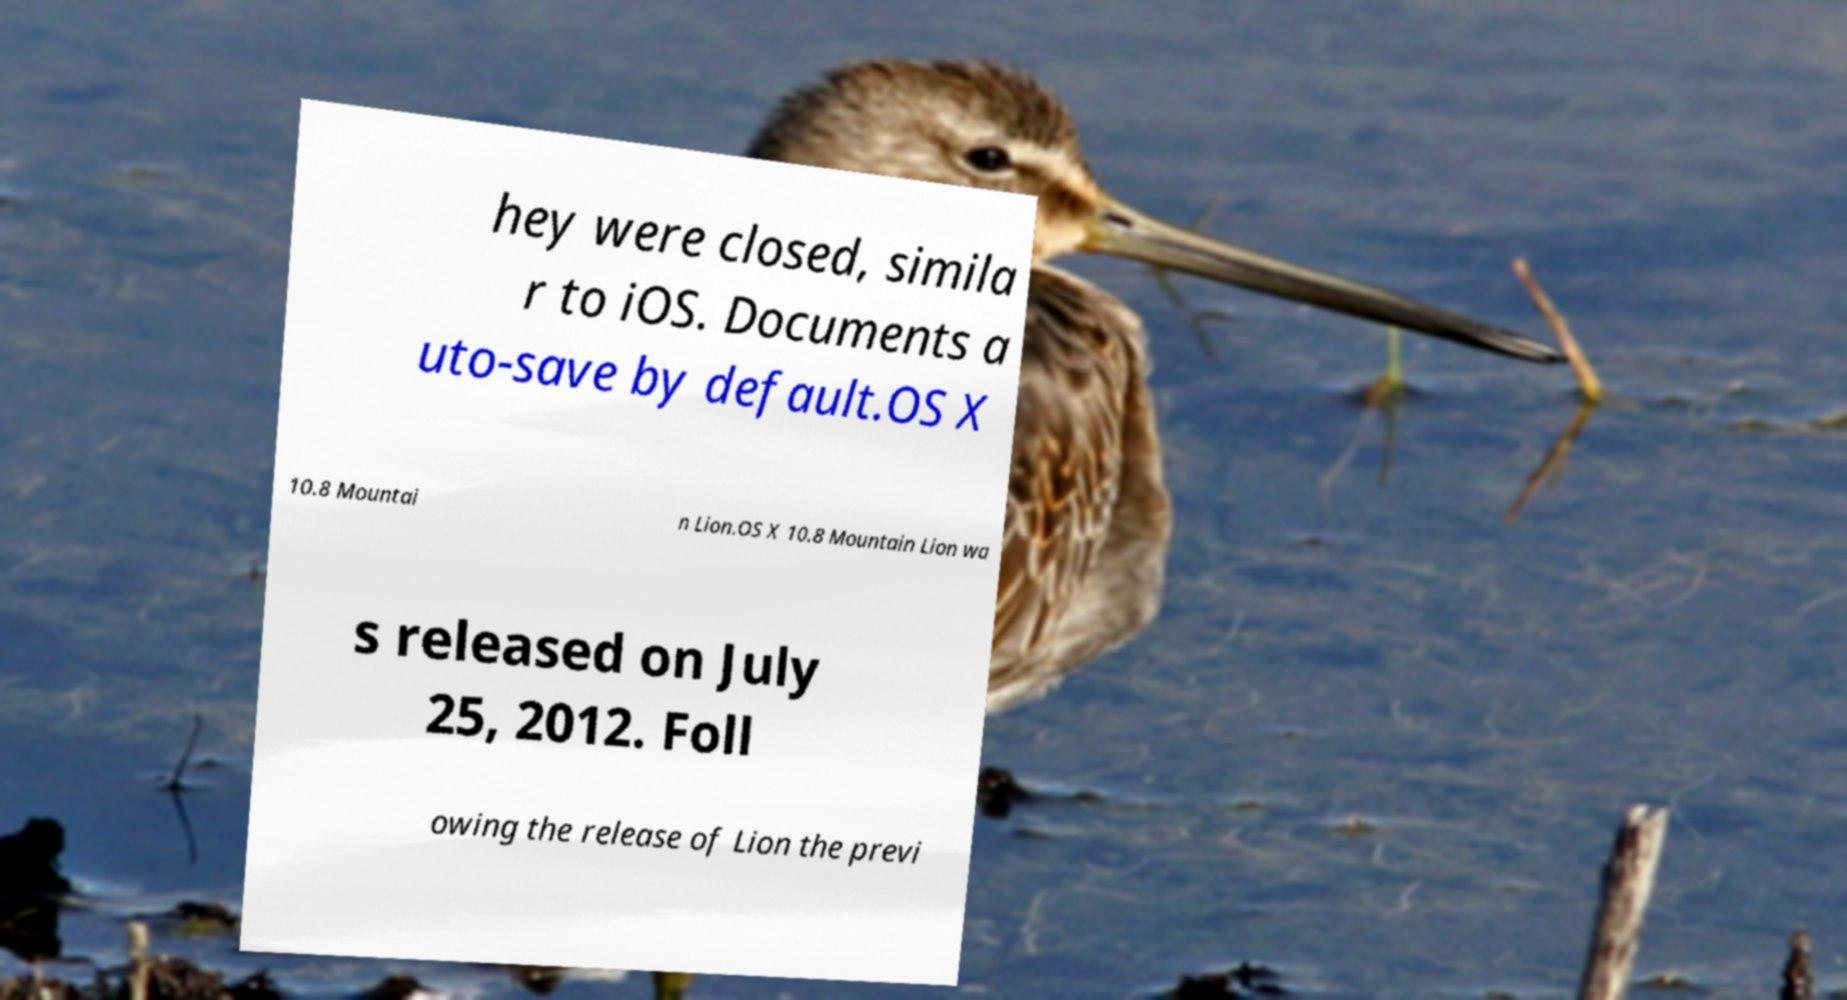Could you extract and type out the text from this image? hey were closed, simila r to iOS. Documents a uto-save by default.OS X 10.8 Mountai n Lion.OS X 10.8 Mountain Lion wa s released on July 25, 2012. Foll owing the release of Lion the previ 